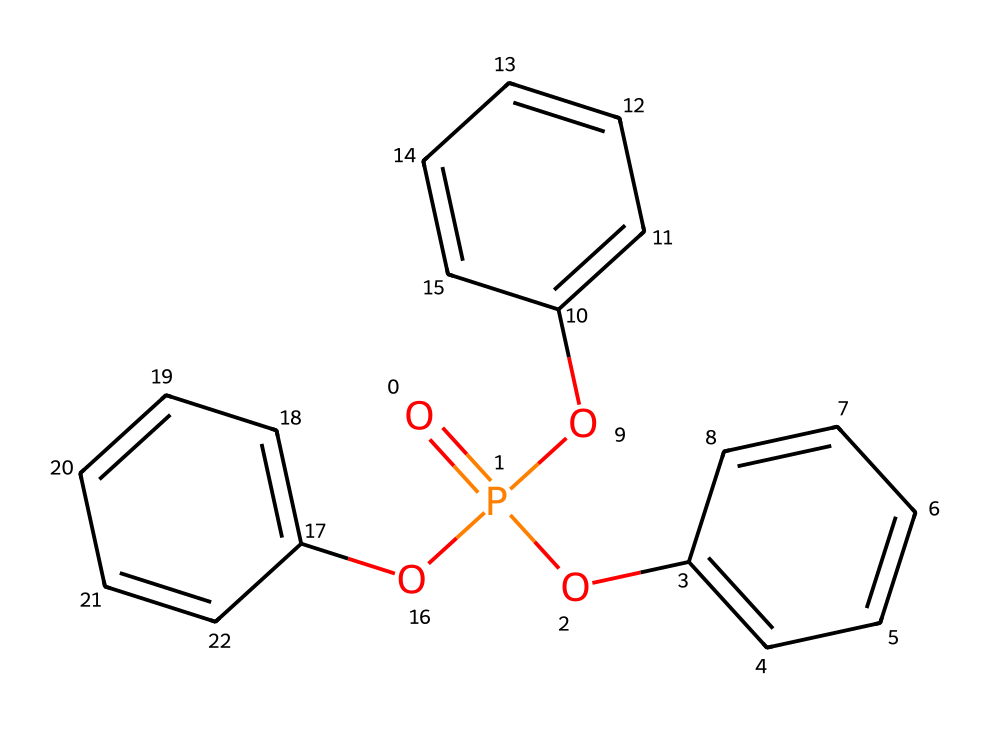What is the molecular formula of triphenyl phosphate? By visualizing the structure, we see that there are three phenyl (C6H5) groups and one phosphate (PO4) group, combined as C18H15O4P.
Answer: C18H15O4P How many phenyl groups are present in the structure of triphenyl phosphate? The structure indicates that there are three distinct phenyl groups attached to the phosphate, evident by the three "Oc" sections connecting to the phosphorus atom.
Answer: three What type of chemical bond connects the phenyl groups to the phosphorus atom? The connection between the phenyl groups and the phosphorus atom is through an ether bond, as shown by the single bond between the oxygen of the phenyl ring and the phosphorus.
Answer: ether What is the functional group present in triphenyl phosphate? The presence of the phosphate group ("P=O" and "O-P" linkages) indicates that the functional group in this compound is a phosphate functional group.
Answer: phosphate How does the structure of triphenyl phosphate contribute to its role as a flame retardant? The presence of the phosphorus atom and its ability to form stable bonds in the presence of heat, combined with the large aromatic rings that can help dissipate heat, contribute to its effectiveness as a flame retardant.
Answer: stability What are the van der Waals interactions associated with triphenyl phosphate? The large phenyl groups create significant van der Waals interactions due to their size and the ability to stack, resulting in enhanced physical properties such as thermal stability.
Answer: stacking interactions 